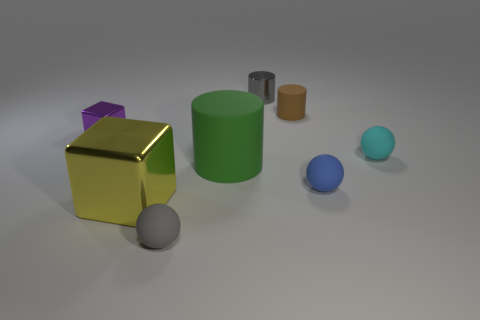Subtract all green cylinders. How many cylinders are left? 2 Add 1 gray shiny blocks. How many objects exist? 9 Subtract all balls. How many objects are left? 5 Subtract all brown cylinders. How many cylinders are left? 2 Subtract 1 blocks. How many blocks are left? 1 Subtract all yellow blocks. Subtract all purple spheres. How many blocks are left? 1 Subtract all gray blocks. How many gray spheres are left? 1 Subtract all yellow cubes. Subtract all blue things. How many objects are left? 6 Add 4 large yellow metal cubes. How many large yellow metal cubes are left? 5 Add 1 big green rubber objects. How many big green rubber objects exist? 2 